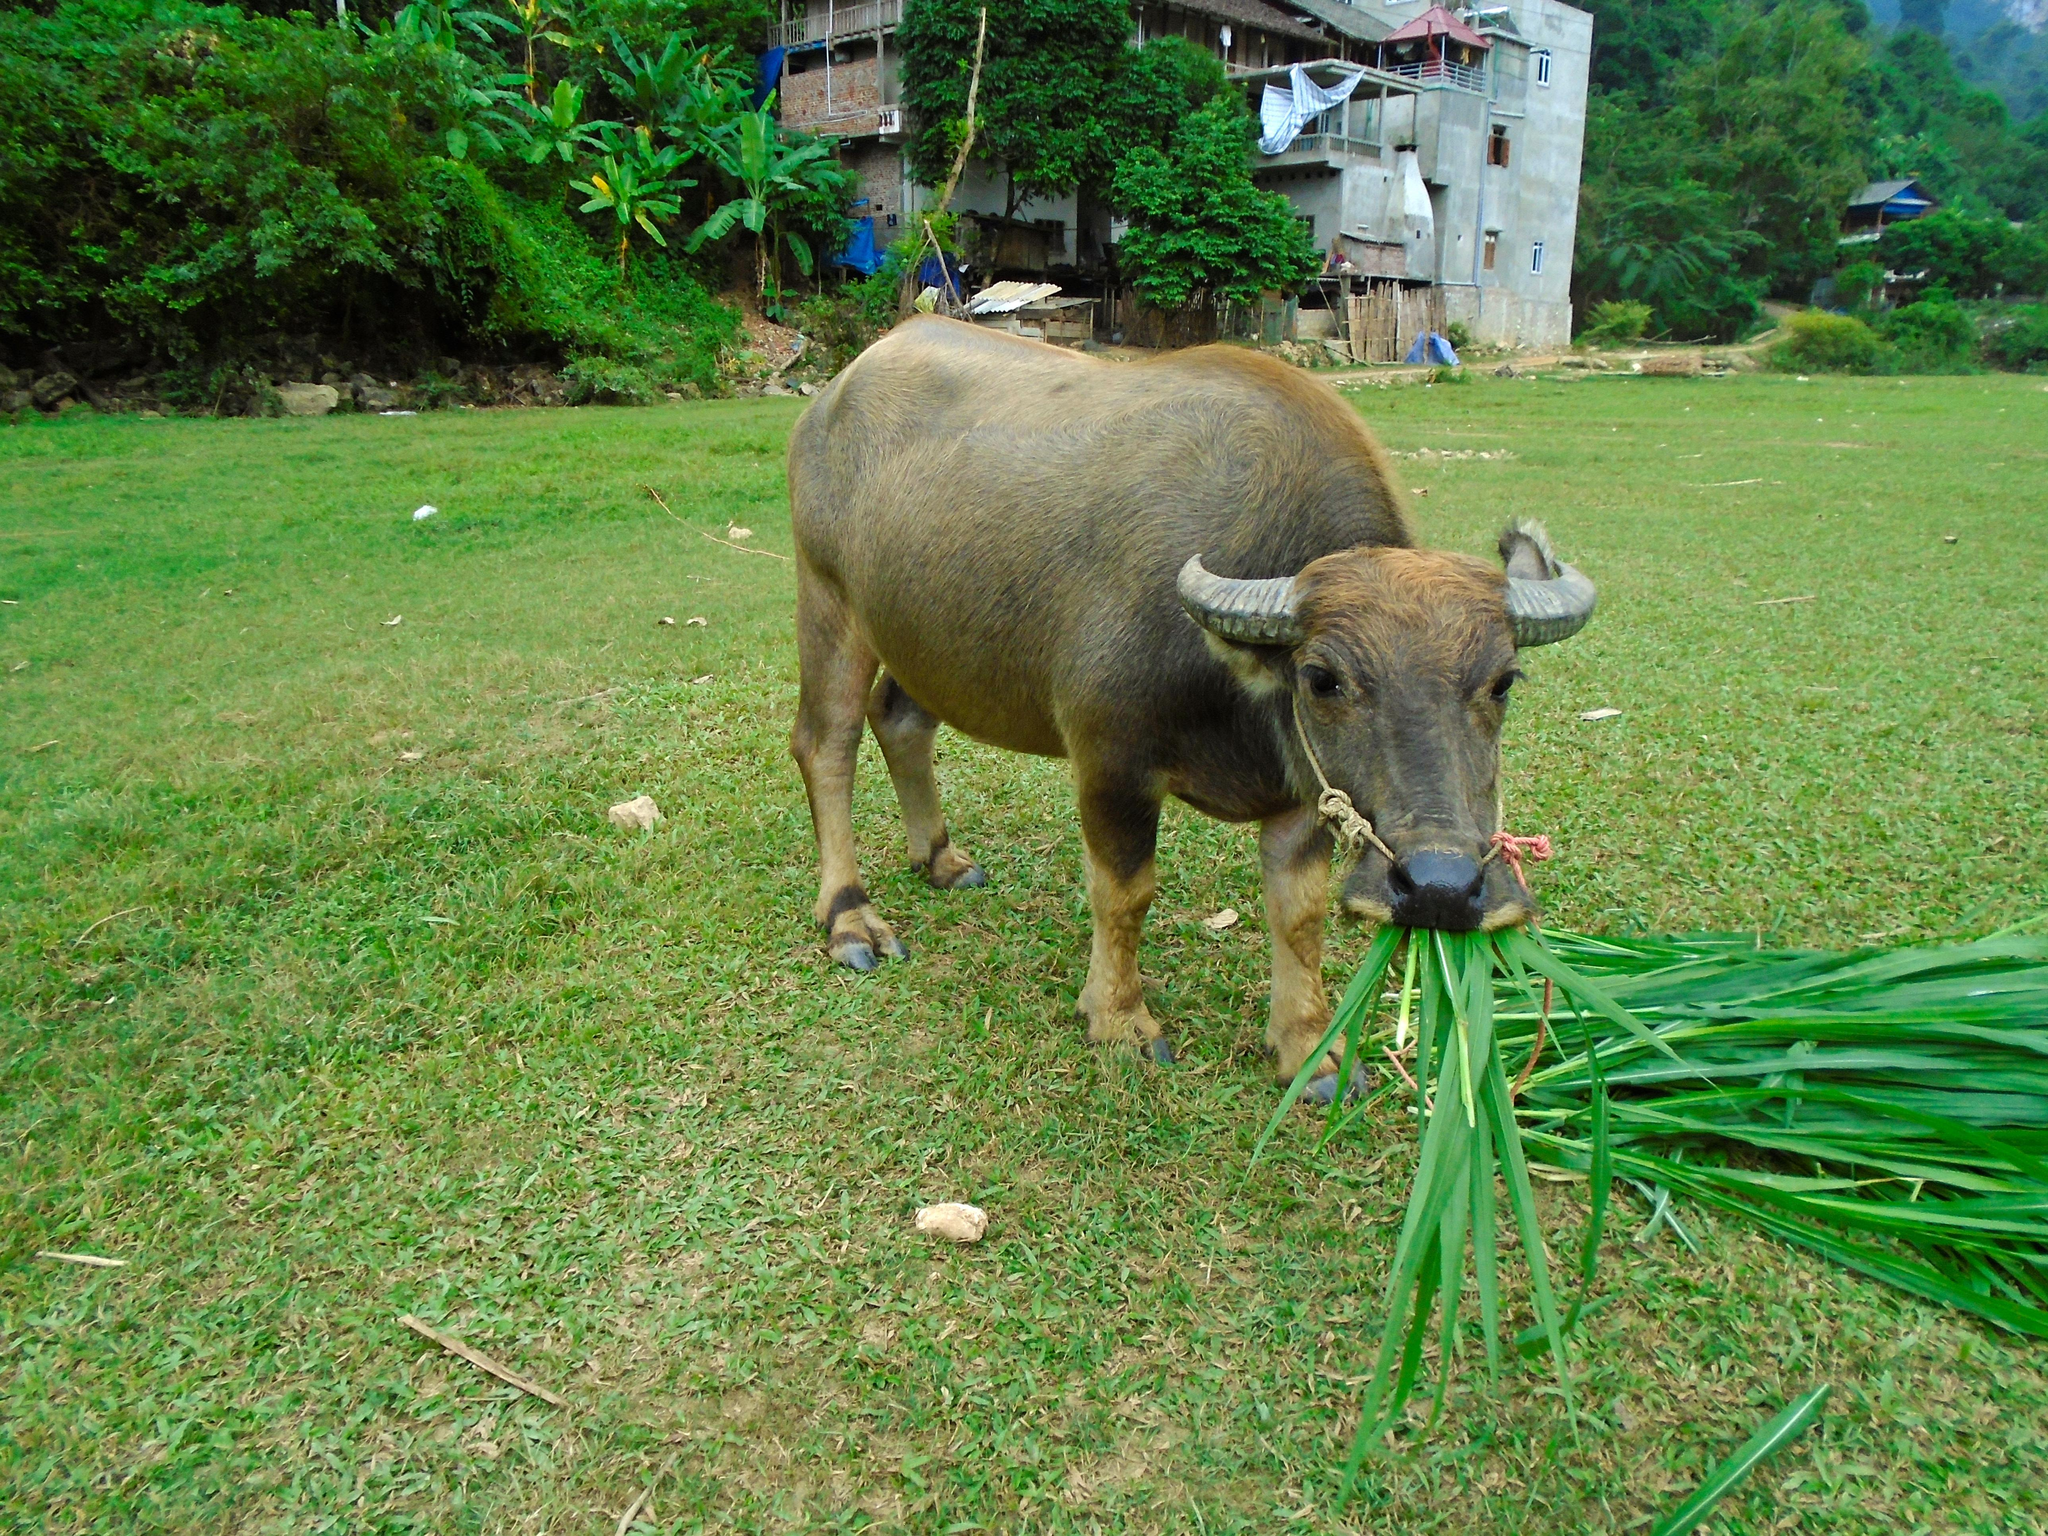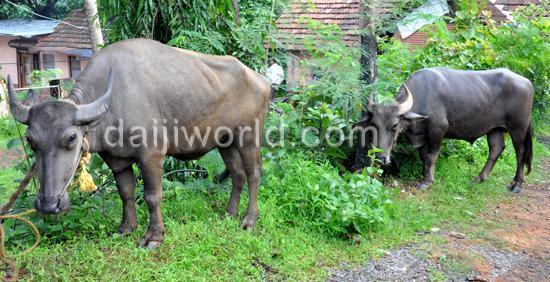The first image is the image on the left, the second image is the image on the right. Analyze the images presented: Is the assertion "a water buffalo is up to it's neck in water" valid? Answer yes or no. No. The first image is the image on the left, the second image is the image on the right. Analyze the images presented: Is the assertion "There is a total of 1 buffalo in water up to their head." valid? Answer yes or no. No. 